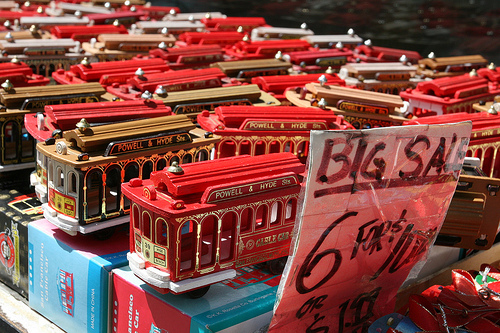<image>
Is there a train on the train? No. The train is not positioned on the train. They may be near each other, but the train is not supported by or resting on top of the train. 